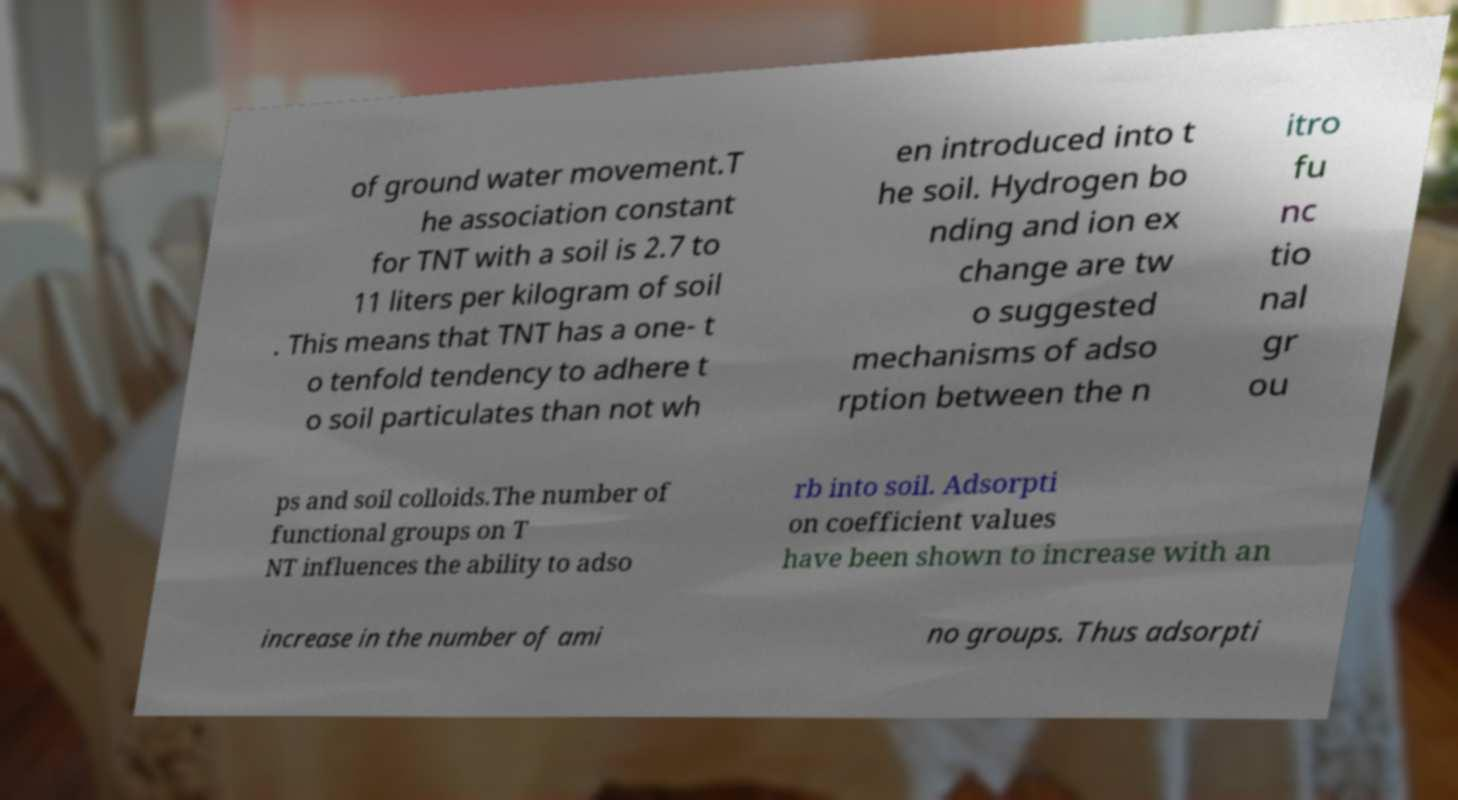For documentation purposes, I need the text within this image transcribed. Could you provide that? of ground water movement.T he association constant for TNT with a soil is 2.7 to 11 liters per kilogram of soil . This means that TNT has a one- t o tenfold tendency to adhere t o soil particulates than not wh en introduced into t he soil. Hydrogen bo nding and ion ex change are tw o suggested mechanisms of adso rption between the n itro fu nc tio nal gr ou ps and soil colloids.The number of functional groups on T NT influences the ability to adso rb into soil. Adsorpti on coefficient values have been shown to increase with an increase in the number of ami no groups. Thus adsorpti 